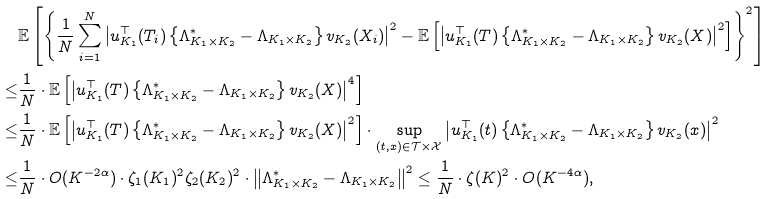<formula> <loc_0><loc_0><loc_500><loc_500>& \mathbb { E } \left [ \left \{ \frac { 1 } { N } \sum _ { i = 1 } ^ { N } \left | u _ { K _ { 1 } } ^ { \top } ( T _ { i } ) \left \{ \Lambda ^ { * } _ { K _ { 1 } \times K _ { 2 } } - \Lambda _ { K _ { 1 } \times K _ { 2 } } \right \} v _ { K _ { 2 } } ( X _ { i } ) \right | ^ { 2 } - \mathbb { E } \left [ \left | u _ { K _ { 1 } } ^ { \top } ( T ) \left \{ \Lambda ^ { * } _ { K _ { 1 } \times K _ { 2 } } - \Lambda _ { K _ { 1 } \times K _ { 2 } } \right \} v _ { K _ { 2 } } ( X ) \right | ^ { 2 } \right ] \right \} ^ { 2 } \right ] \\ \leq & \frac { 1 } { N } \cdot \mathbb { E } \left [ \left | u _ { K _ { 1 } } ^ { \top } ( T ) \left \{ \Lambda ^ { * } _ { K _ { 1 } \times K _ { 2 } } - \Lambda _ { K _ { 1 } \times K _ { 2 } } \right \} v _ { K _ { 2 } } ( X ) \right | ^ { 4 } \right ] \\ \leq & \frac { 1 } { N } \cdot \mathbb { E } \left [ \left | u _ { K _ { 1 } } ^ { \top } ( T ) \left \{ \Lambda ^ { * } _ { K _ { 1 } \times K _ { 2 } } - \Lambda _ { K _ { 1 } \times K _ { 2 } } \right \} v _ { K _ { 2 } } ( X ) \right | ^ { 2 } \right ] \cdot \sup _ { ( t , x ) \in \mathcal { T } \times \mathcal { X } } \left | u _ { K _ { 1 } } ^ { \top } ( t ) \left \{ \Lambda ^ { * } _ { K _ { 1 } \times K _ { 2 } } - \Lambda _ { K _ { 1 } \times K _ { 2 } } \right \} v _ { K _ { 2 } } ( x ) \right | ^ { 2 } \\ \leq & \frac { 1 } { N } \cdot O ( K ^ { - 2 \alpha } ) \cdot \zeta _ { 1 } ( K _ { 1 } ) ^ { 2 } \zeta _ { 2 } ( K _ { 2 } ) ^ { 2 } \cdot \left \| \Lambda ^ { * } _ { K _ { 1 } \times K _ { 2 } } - \Lambda _ { K _ { 1 } \times K _ { 2 } } \right \| ^ { 2 } \leq \frac { 1 } { N } \cdot \zeta ( K ) ^ { 2 } \cdot O ( K ^ { - 4 \alpha } ) ,</formula> 